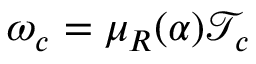<formula> <loc_0><loc_0><loc_500><loc_500>{ \omega } _ { c } = \mu _ { R } ( \alpha ) { \mathcal { T } } _ { c }</formula> 